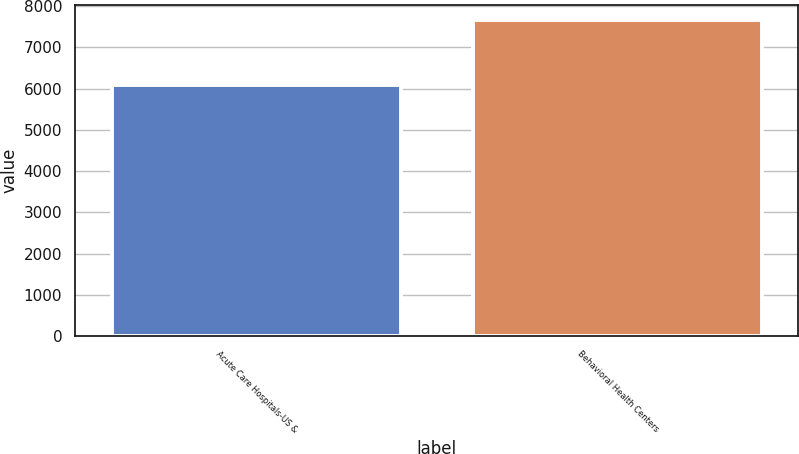Convert chart to OTSL. <chart><loc_0><loc_0><loc_500><loc_500><bar_chart><fcel>Acute Care Hospitals-US &<fcel>Behavioral Health Centers<nl><fcel>6101<fcel>7658<nl></chart> 